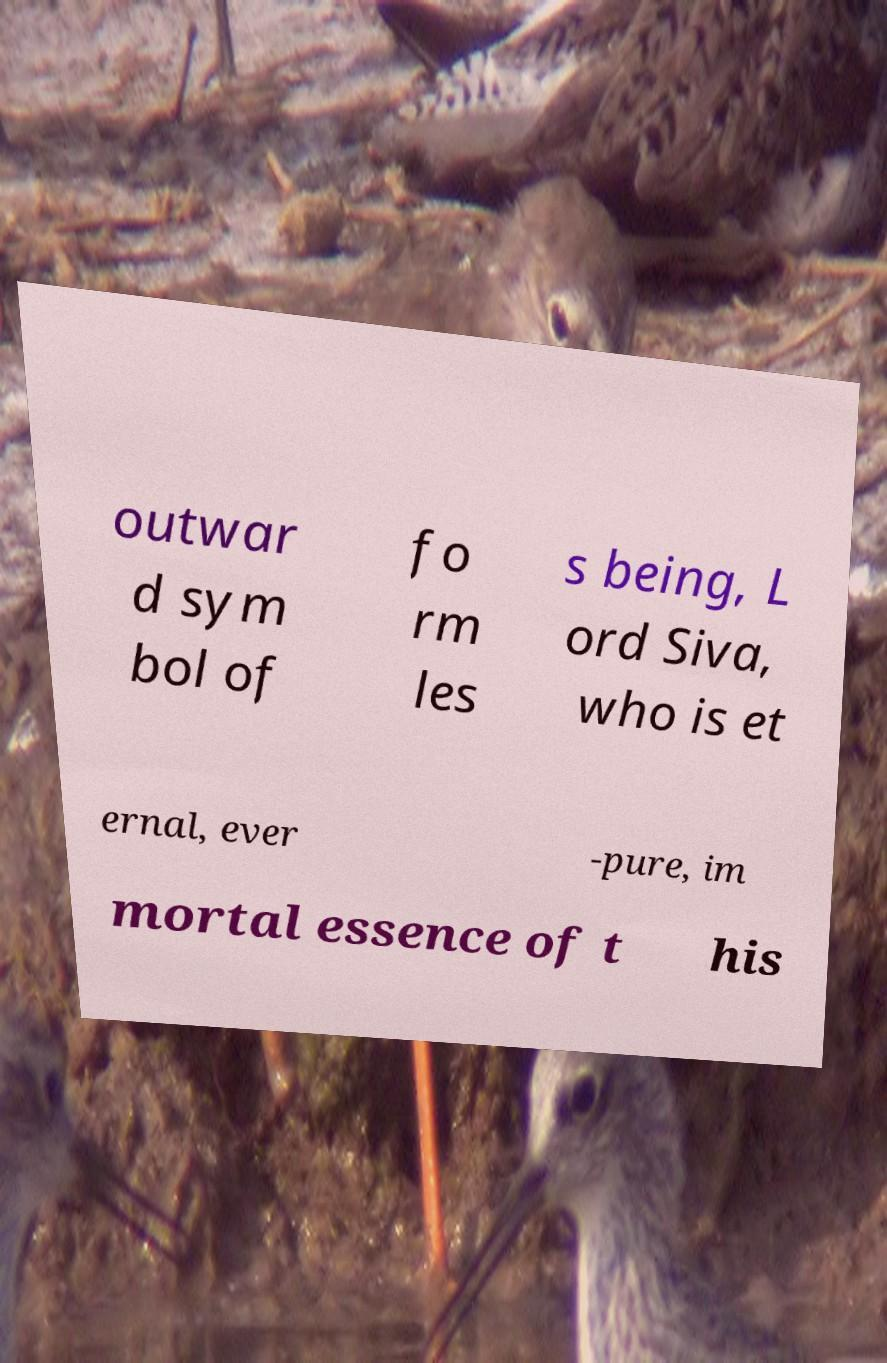There's text embedded in this image that I need extracted. Can you transcribe it verbatim? outwar d sym bol of fo rm les s being, L ord Siva, who is et ernal, ever -pure, im mortal essence of t his 